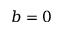<formula> <loc_0><loc_0><loc_500><loc_500>b = 0</formula> 